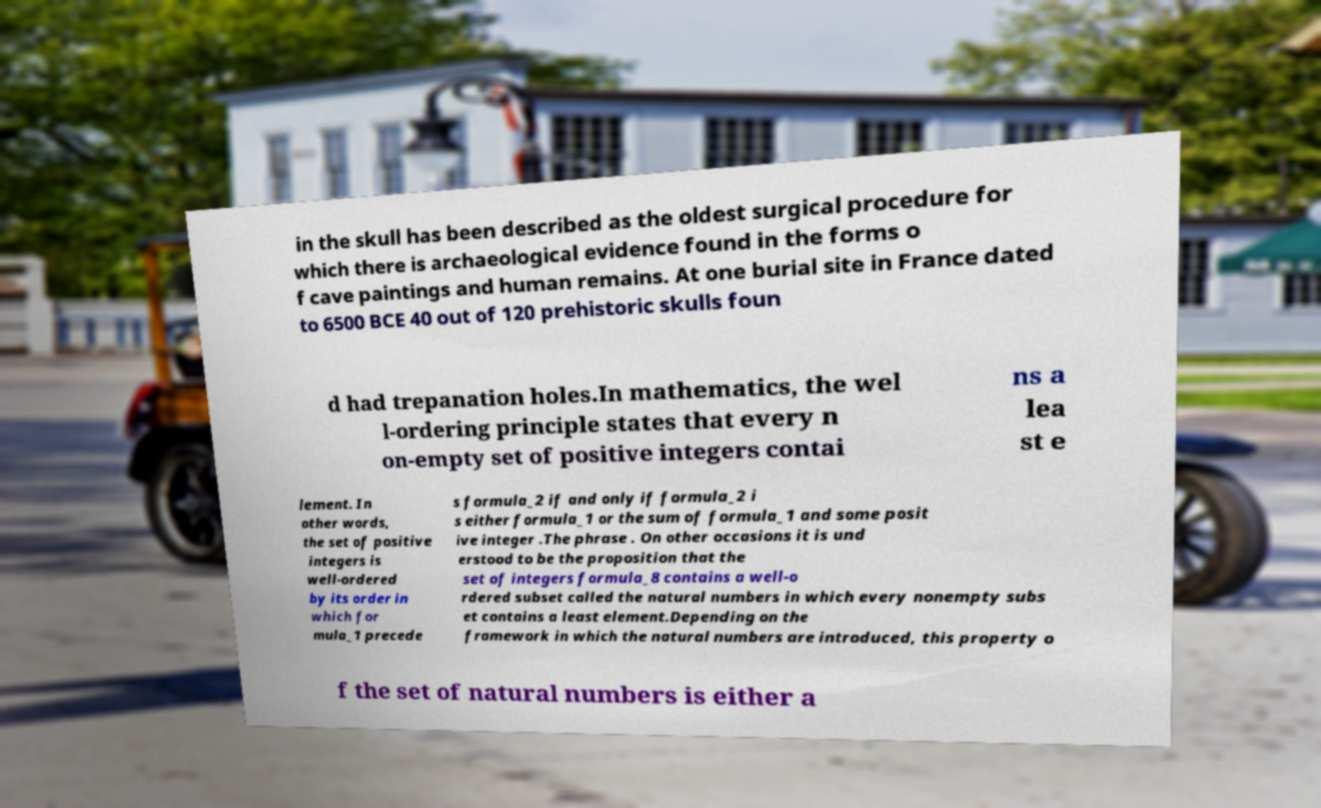Could you assist in decoding the text presented in this image and type it out clearly? in the skull has been described as the oldest surgical procedure for which there is archaeological evidence found in the forms o f cave paintings and human remains. At one burial site in France dated to 6500 BCE 40 out of 120 prehistoric skulls foun d had trepanation holes.In mathematics, the wel l-ordering principle states that every n on-empty set of positive integers contai ns a lea st e lement. In other words, the set of positive integers is well-ordered by its order in which for mula_1 precede s formula_2 if and only if formula_2 i s either formula_1 or the sum of formula_1 and some posit ive integer .The phrase . On other occasions it is und erstood to be the proposition that the set of integers formula_8 contains a well-o rdered subset called the natural numbers in which every nonempty subs et contains a least element.Depending on the framework in which the natural numbers are introduced, this property o f the set of natural numbers is either a 